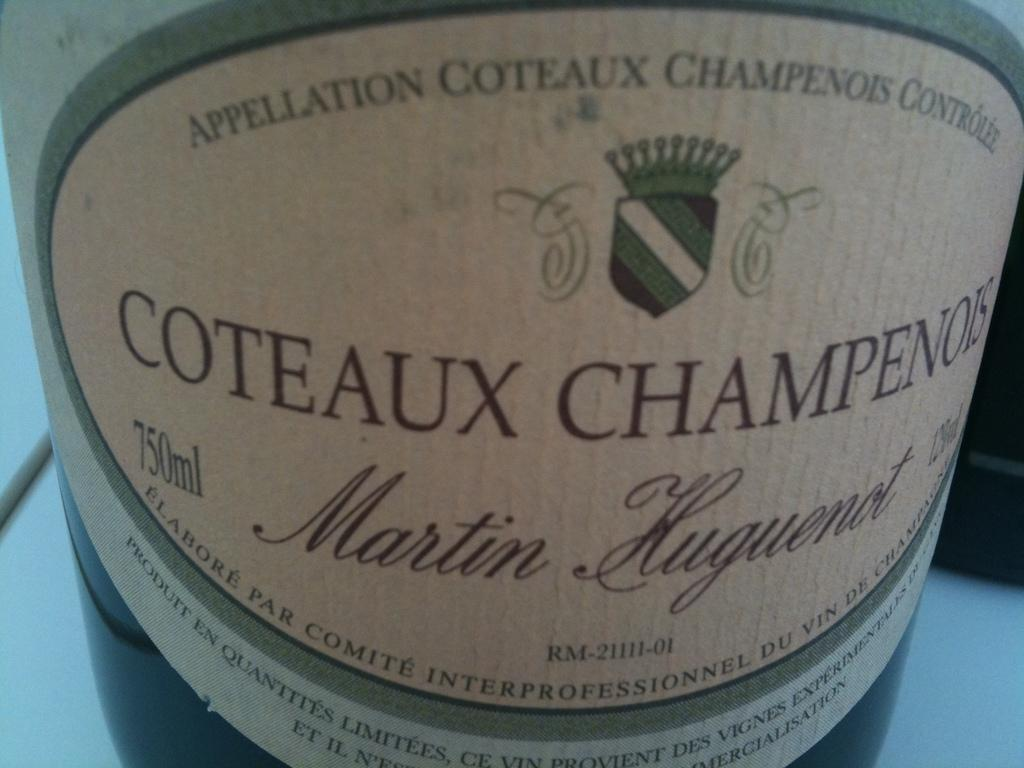Provide a one-sentence caption for the provided image. Coteaux Champenois sits on a white clothed table. 